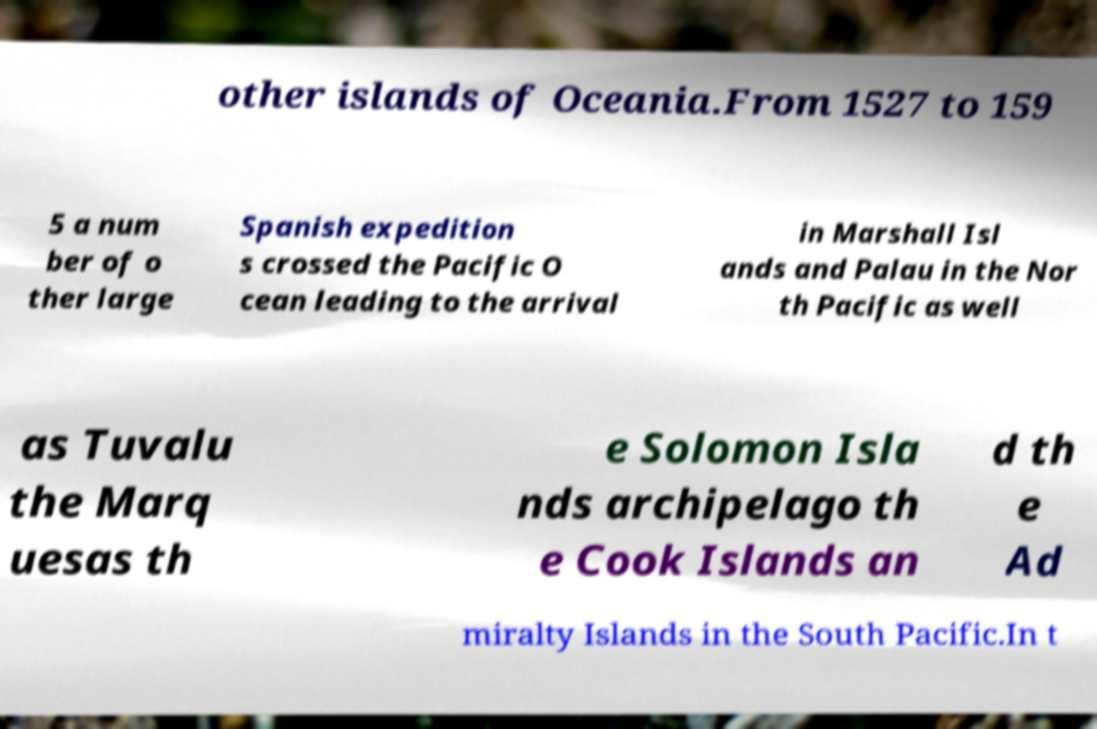I need the written content from this picture converted into text. Can you do that? other islands of Oceania.From 1527 to 159 5 a num ber of o ther large Spanish expedition s crossed the Pacific O cean leading to the arrival in Marshall Isl ands and Palau in the Nor th Pacific as well as Tuvalu the Marq uesas th e Solomon Isla nds archipelago th e Cook Islands an d th e Ad miralty Islands in the South Pacific.In t 